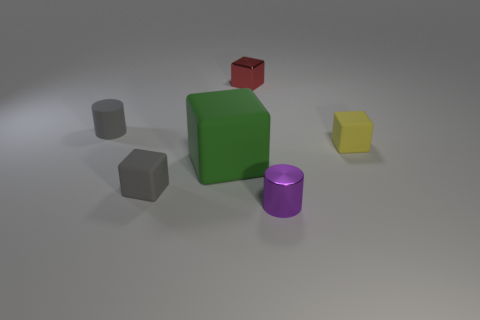Are there any other things that are the same size as the gray cylinder?
Offer a very short reply. Yes. There is a block that is the same color as the rubber cylinder; what material is it?
Offer a terse response. Rubber. What size is the cube that is the same color as the matte cylinder?
Provide a succinct answer. Small. Do the small cylinder that is behind the green cube and the matte cube right of the small purple metallic thing have the same color?
Ensure brevity in your answer.  No. How many things are either matte cubes or gray matte things?
Your response must be concise. 4. What number of other things are there of the same shape as the tiny red thing?
Give a very brief answer. 3. Are the gray object that is behind the tiny yellow cube and the cube that is on the right side of the tiny red block made of the same material?
Your answer should be compact. Yes. There is a object that is to the right of the small red cube and in front of the large cube; what shape is it?
Provide a succinct answer. Cylinder. Is there anything else that has the same material as the gray cylinder?
Make the answer very short. Yes. There is a object that is both to the left of the large green object and in front of the large green matte block; what is its material?
Give a very brief answer. Rubber. 